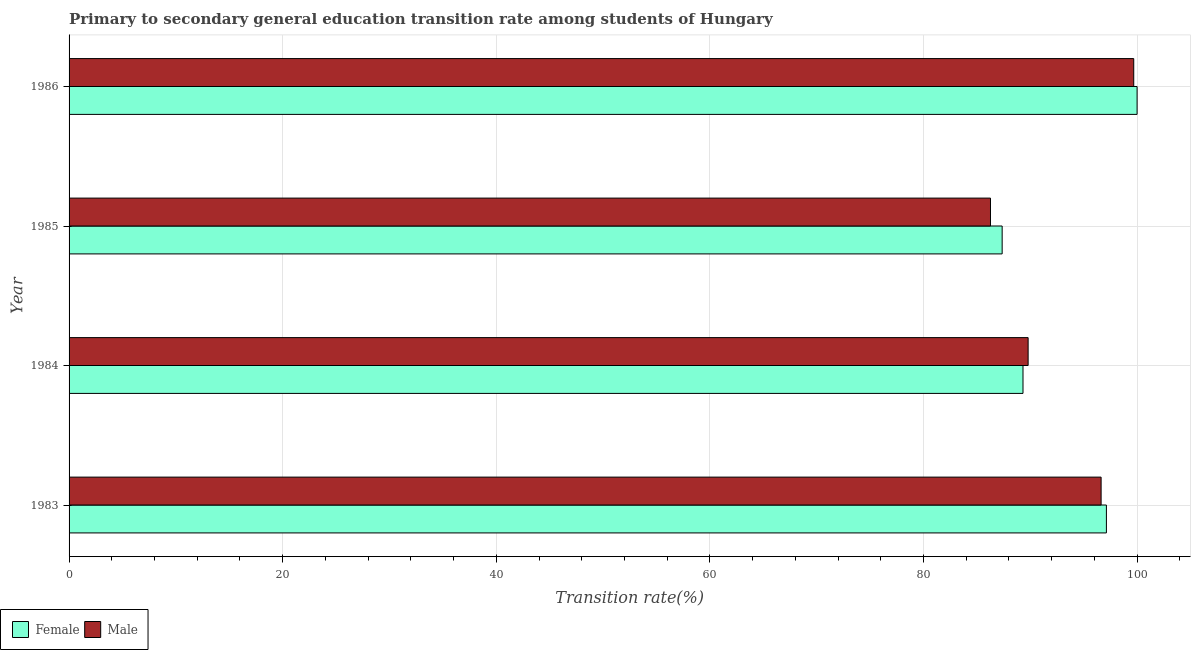How many different coloured bars are there?
Your answer should be very brief. 2. How many groups of bars are there?
Your answer should be compact. 4. Are the number of bars on each tick of the Y-axis equal?
Provide a short and direct response. Yes. How many bars are there on the 3rd tick from the bottom?
Your response must be concise. 2. What is the label of the 3rd group of bars from the top?
Provide a succinct answer. 1984. In how many cases, is the number of bars for a given year not equal to the number of legend labels?
Offer a terse response. 0. What is the transition rate among female students in 1985?
Your answer should be very brief. 87.37. Across all years, what is the maximum transition rate among female students?
Your answer should be compact. 100. Across all years, what is the minimum transition rate among female students?
Your answer should be very brief. 87.37. In which year was the transition rate among female students maximum?
Provide a succinct answer. 1986. What is the total transition rate among male students in the graph?
Keep it short and to the point. 372.39. What is the difference between the transition rate among female students in 1984 and that in 1986?
Your answer should be very brief. -10.68. What is the difference between the transition rate among female students in 1985 and the transition rate among male students in 1983?
Provide a short and direct response. -9.27. What is the average transition rate among male students per year?
Provide a short and direct response. 93.1. In the year 1983, what is the difference between the transition rate among female students and transition rate among male students?
Your answer should be compact. 0.5. In how many years, is the transition rate among male students greater than 40 %?
Provide a short and direct response. 4. What is the ratio of the transition rate among male students in 1984 to that in 1986?
Your response must be concise. 0.9. Is the transition rate among male students in 1983 less than that in 1984?
Give a very brief answer. No. Is the difference between the transition rate among female students in 1984 and 1985 greater than the difference between the transition rate among male students in 1984 and 1985?
Your response must be concise. No. What is the difference between the highest and the second highest transition rate among male students?
Give a very brief answer. 3.05. What is the difference between the highest and the lowest transition rate among female students?
Provide a short and direct response. 12.63. What does the 2nd bar from the bottom in 1985 represents?
Keep it short and to the point. Male. Are all the bars in the graph horizontal?
Provide a succinct answer. Yes. How many years are there in the graph?
Your answer should be compact. 4. What is the difference between two consecutive major ticks on the X-axis?
Ensure brevity in your answer.  20. Does the graph contain any zero values?
Your answer should be compact. No. Where does the legend appear in the graph?
Your answer should be compact. Bottom left. How many legend labels are there?
Your answer should be very brief. 2. What is the title of the graph?
Your answer should be very brief. Primary to secondary general education transition rate among students of Hungary. Does "Underweight" appear as one of the legend labels in the graph?
Your response must be concise. No. What is the label or title of the X-axis?
Give a very brief answer. Transition rate(%). What is the Transition rate(%) in Female in 1983?
Give a very brief answer. 97.13. What is the Transition rate(%) in Male in 1983?
Offer a very short reply. 96.63. What is the Transition rate(%) in Female in 1984?
Provide a succinct answer. 89.32. What is the Transition rate(%) of Male in 1984?
Your answer should be compact. 89.8. What is the Transition rate(%) in Female in 1985?
Your response must be concise. 87.37. What is the Transition rate(%) of Male in 1985?
Your answer should be very brief. 86.27. What is the Transition rate(%) in Male in 1986?
Keep it short and to the point. 99.69. Across all years, what is the maximum Transition rate(%) in Female?
Your answer should be compact. 100. Across all years, what is the maximum Transition rate(%) in Male?
Your answer should be compact. 99.69. Across all years, what is the minimum Transition rate(%) in Female?
Offer a very short reply. 87.37. Across all years, what is the minimum Transition rate(%) in Male?
Offer a very short reply. 86.27. What is the total Transition rate(%) of Female in the graph?
Your response must be concise. 373.81. What is the total Transition rate(%) in Male in the graph?
Your answer should be very brief. 372.39. What is the difference between the Transition rate(%) in Female in 1983 and that in 1984?
Give a very brief answer. 7.81. What is the difference between the Transition rate(%) of Male in 1983 and that in 1984?
Give a very brief answer. 6.83. What is the difference between the Transition rate(%) in Female in 1983 and that in 1985?
Make the answer very short. 9.76. What is the difference between the Transition rate(%) in Male in 1983 and that in 1985?
Offer a terse response. 10.36. What is the difference between the Transition rate(%) of Female in 1983 and that in 1986?
Your answer should be very brief. -2.87. What is the difference between the Transition rate(%) of Male in 1983 and that in 1986?
Your answer should be very brief. -3.05. What is the difference between the Transition rate(%) of Female in 1984 and that in 1985?
Your answer should be compact. 1.95. What is the difference between the Transition rate(%) of Male in 1984 and that in 1985?
Offer a very short reply. 3.52. What is the difference between the Transition rate(%) of Female in 1984 and that in 1986?
Your answer should be compact. -10.68. What is the difference between the Transition rate(%) of Male in 1984 and that in 1986?
Ensure brevity in your answer.  -9.89. What is the difference between the Transition rate(%) in Female in 1985 and that in 1986?
Your answer should be very brief. -12.63. What is the difference between the Transition rate(%) in Male in 1985 and that in 1986?
Offer a terse response. -13.41. What is the difference between the Transition rate(%) of Female in 1983 and the Transition rate(%) of Male in 1984?
Ensure brevity in your answer.  7.33. What is the difference between the Transition rate(%) of Female in 1983 and the Transition rate(%) of Male in 1985?
Ensure brevity in your answer.  10.85. What is the difference between the Transition rate(%) of Female in 1983 and the Transition rate(%) of Male in 1986?
Give a very brief answer. -2.56. What is the difference between the Transition rate(%) of Female in 1984 and the Transition rate(%) of Male in 1985?
Give a very brief answer. 3.04. What is the difference between the Transition rate(%) of Female in 1984 and the Transition rate(%) of Male in 1986?
Offer a very short reply. -10.37. What is the difference between the Transition rate(%) in Female in 1985 and the Transition rate(%) in Male in 1986?
Keep it short and to the point. -12.32. What is the average Transition rate(%) in Female per year?
Your answer should be very brief. 93.45. What is the average Transition rate(%) in Male per year?
Offer a terse response. 93.1. In the year 1983, what is the difference between the Transition rate(%) of Female and Transition rate(%) of Male?
Offer a very short reply. 0.5. In the year 1984, what is the difference between the Transition rate(%) of Female and Transition rate(%) of Male?
Provide a succinct answer. -0.48. In the year 1985, what is the difference between the Transition rate(%) in Female and Transition rate(%) in Male?
Keep it short and to the point. 1.09. In the year 1986, what is the difference between the Transition rate(%) in Female and Transition rate(%) in Male?
Your answer should be compact. 0.31. What is the ratio of the Transition rate(%) in Female in 1983 to that in 1984?
Provide a succinct answer. 1.09. What is the ratio of the Transition rate(%) in Male in 1983 to that in 1984?
Provide a succinct answer. 1.08. What is the ratio of the Transition rate(%) in Female in 1983 to that in 1985?
Your answer should be very brief. 1.11. What is the ratio of the Transition rate(%) of Male in 1983 to that in 1985?
Ensure brevity in your answer.  1.12. What is the ratio of the Transition rate(%) of Female in 1983 to that in 1986?
Provide a short and direct response. 0.97. What is the ratio of the Transition rate(%) in Male in 1983 to that in 1986?
Offer a very short reply. 0.97. What is the ratio of the Transition rate(%) in Female in 1984 to that in 1985?
Keep it short and to the point. 1.02. What is the ratio of the Transition rate(%) in Male in 1984 to that in 1985?
Your answer should be compact. 1.04. What is the ratio of the Transition rate(%) in Female in 1984 to that in 1986?
Ensure brevity in your answer.  0.89. What is the ratio of the Transition rate(%) in Male in 1984 to that in 1986?
Ensure brevity in your answer.  0.9. What is the ratio of the Transition rate(%) of Female in 1985 to that in 1986?
Offer a terse response. 0.87. What is the ratio of the Transition rate(%) in Male in 1985 to that in 1986?
Your response must be concise. 0.87. What is the difference between the highest and the second highest Transition rate(%) of Female?
Make the answer very short. 2.87. What is the difference between the highest and the second highest Transition rate(%) of Male?
Your answer should be compact. 3.05. What is the difference between the highest and the lowest Transition rate(%) in Female?
Ensure brevity in your answer.  12.63. What is the difference between the highest and the lowest Transition rate(%) of Male?
Keep it short and to the point. 13.41. 